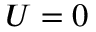Convert formula to latex. <formula><loc_0><loc_0><loc_500><loc_500>U = 0</formula> 